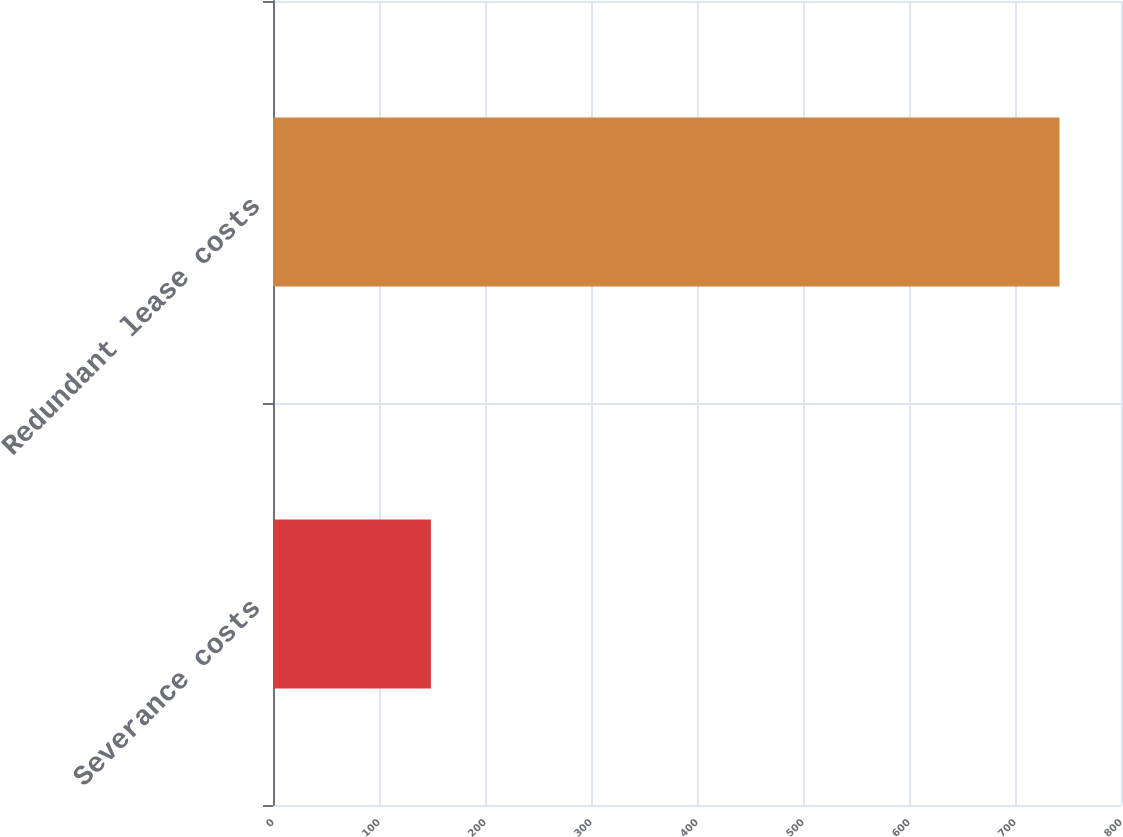Convert chart to OTSL. <chart><loc_0><loc_0><loc_500><loc_500><bar_chart><fcel>Severance costs<fcel>Redundant lease costs<nl><fcel>149<fcel>742<nl></chart> 